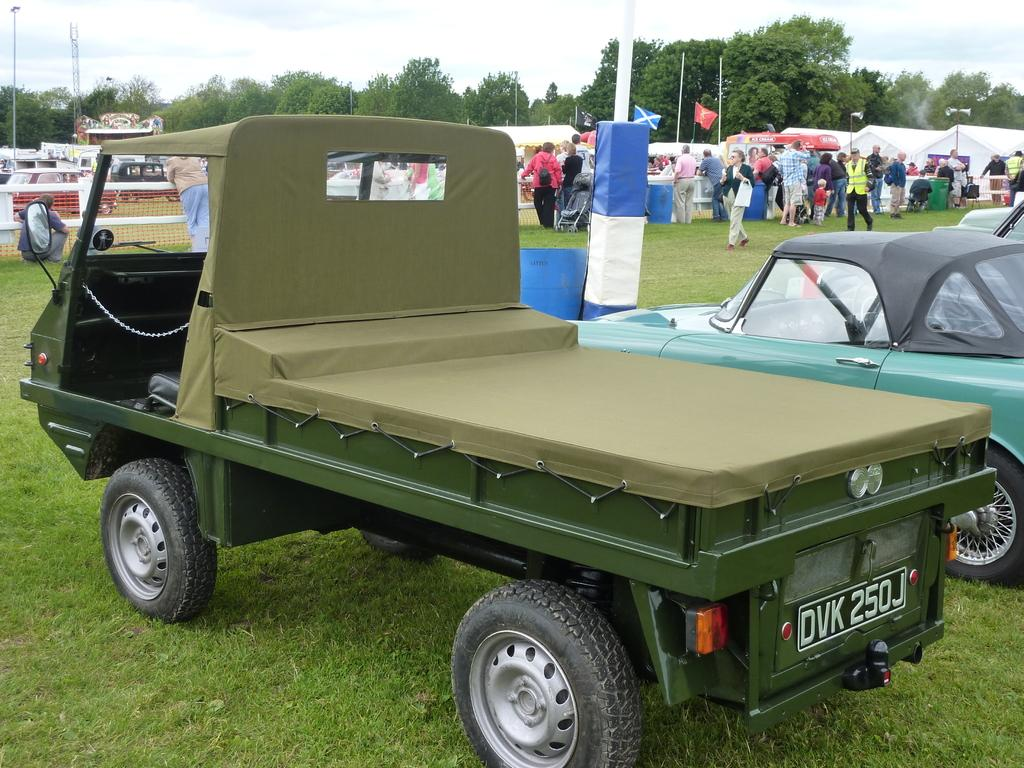What types of objects can be seen in the image? There are vehicles, trees, poles, net fencing, flags, tents, and people in the image. What are the people in the image doing? Some people are standing, and others are walking in the image. What is the color of the sky in the image? The sky is in white and blue color in the image. What type of trouble can be seen in the image? There is no trouble depicted in the image; it features various objects and people engaged in different activities. Can you tell me how many pails are visible in the image? There are no pails present in the image. 